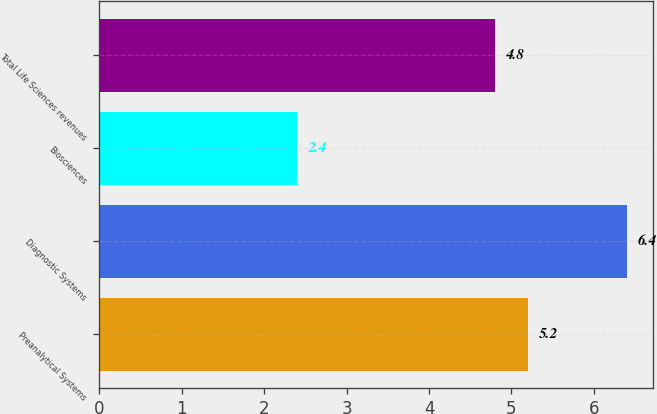Convert chart to OTSL. <chart><loc_0><loc_0><loc_500><loc_500><bar_chart><fcel>Preanalytical Systems<fcel>Diagnostic Systems<fcel>Biosciences<fcel>Total Life Sciences revenues<nl><fcel>5.2<fcel>6.4<fcel>2.4<fcel>4.8<nl></chart> 